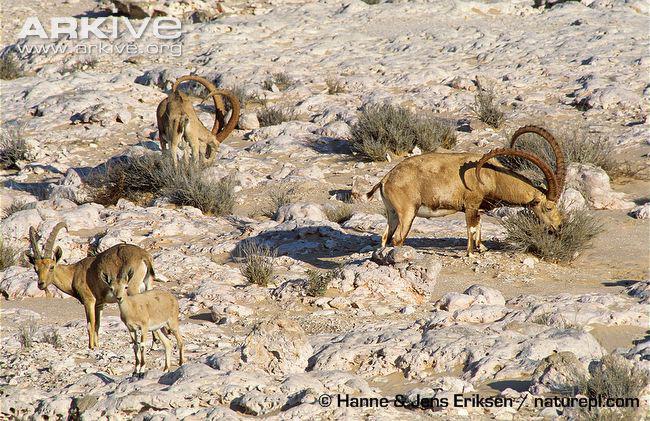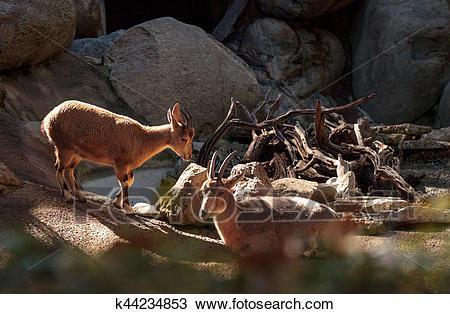The first image is the image on the left, the second image is the image on the right. For the images shown, is this caption "Each image contains only one horned animal, and one image shows an animal with long curled horns, while the other shows an animal with much shorter horns." true? Answer yes or no. No. 